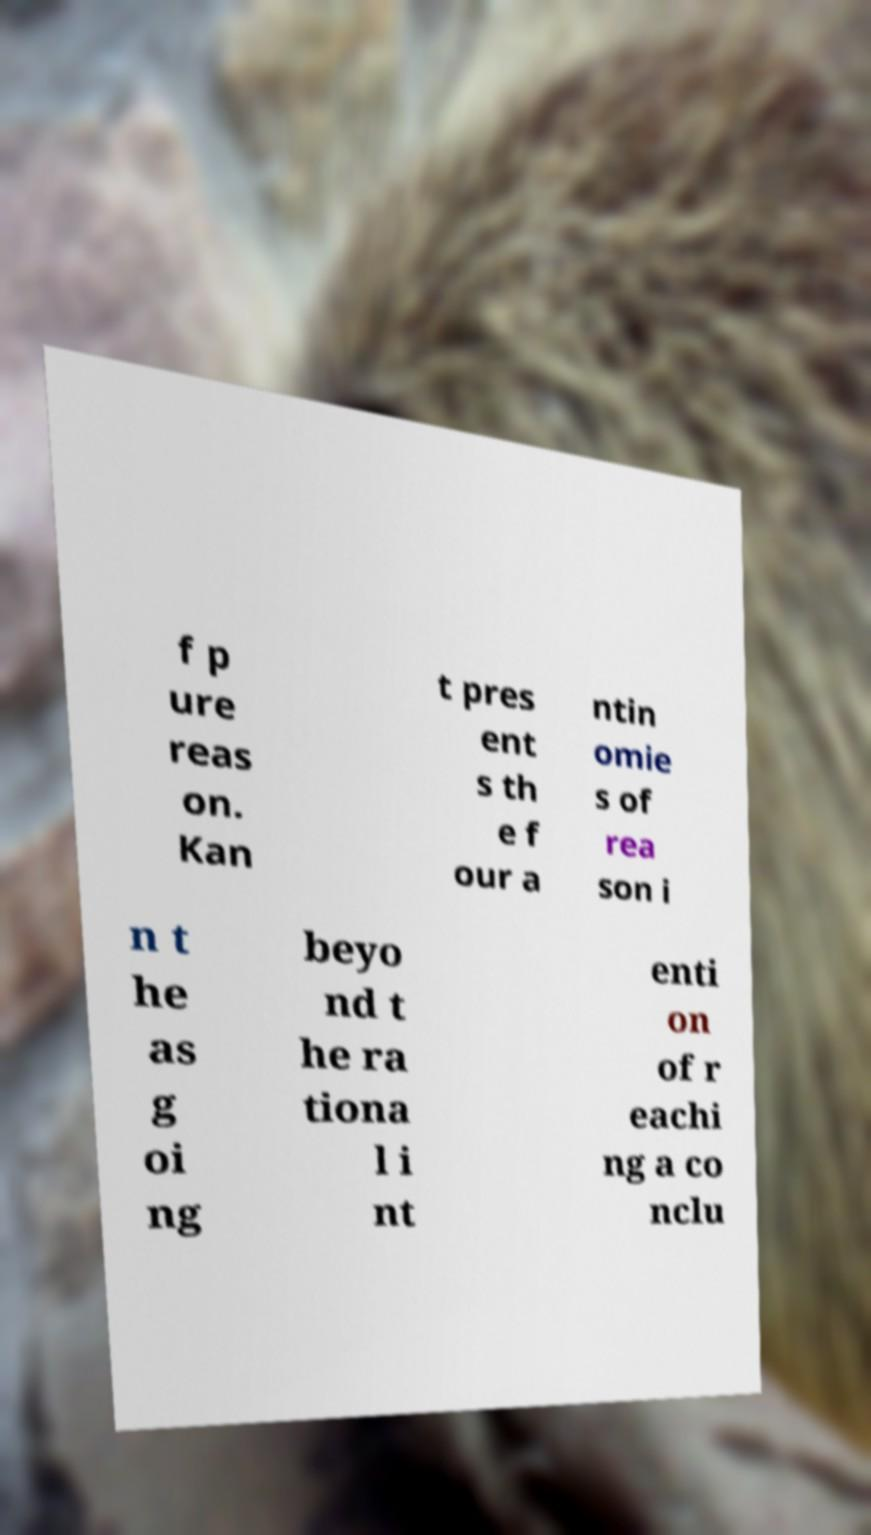Could you assist in decoding the text presented in this image and type it out clearly? f p ure reas on. Kan t pres ent s th e f our a ntin omie s of rea son i n t he as g oi ng beyo nd t he ra tiona l i nt enti on of r eachi ng a co nclu 